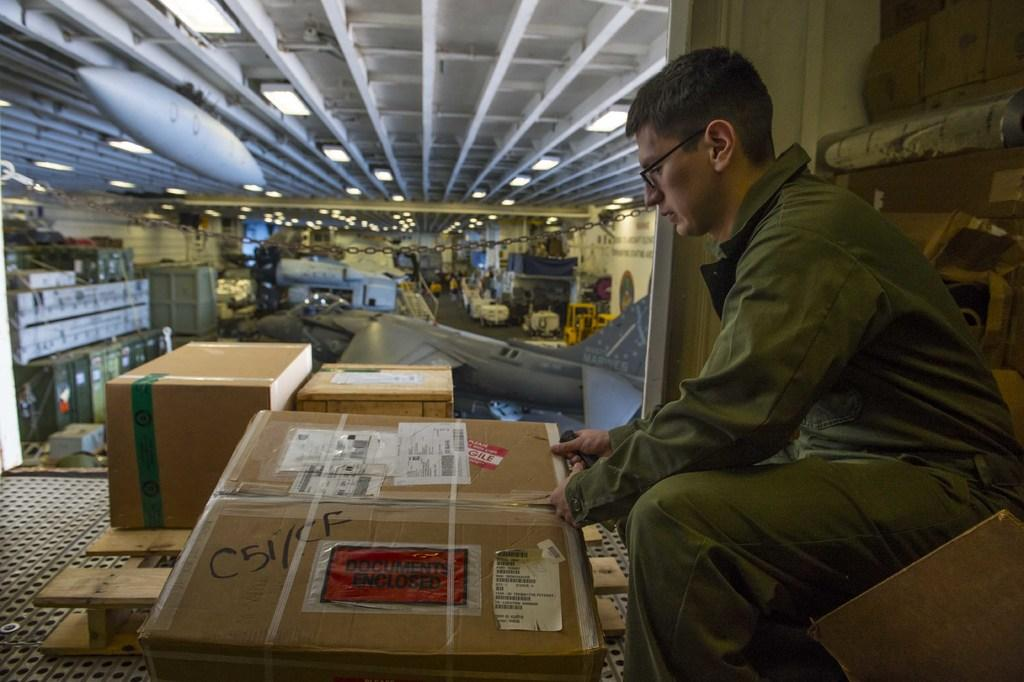<image>
Relay a brief, clear account of the picture shown. A person opening a large cardboard box that says "Documents Enclosed". 